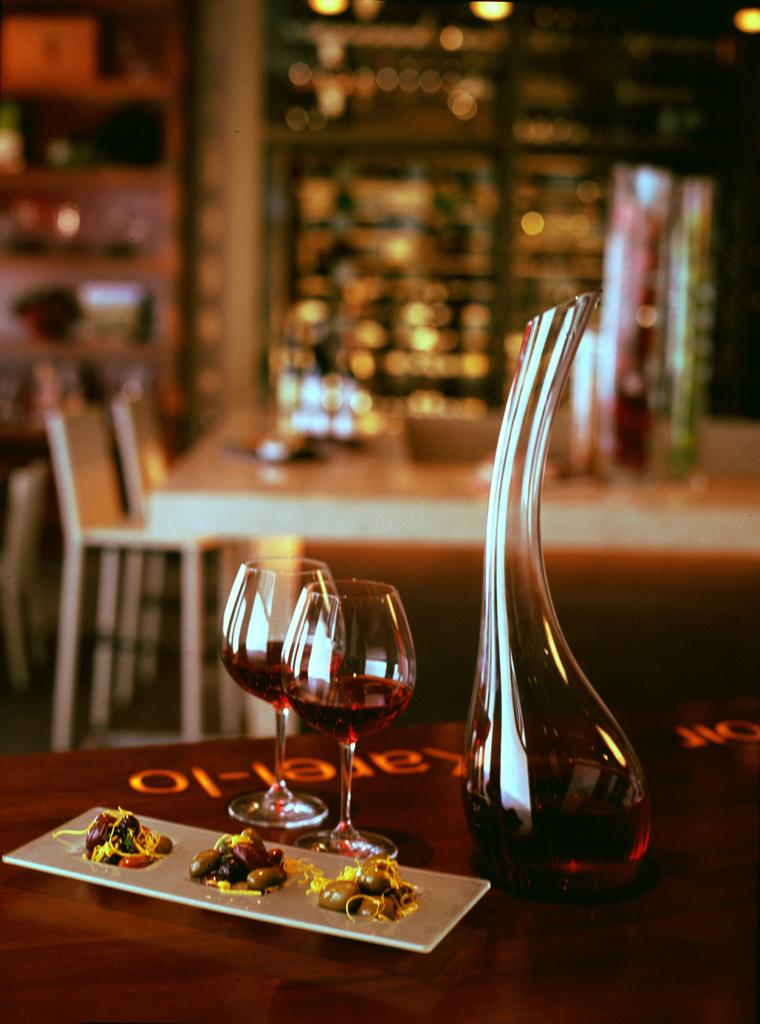What type of glassware can be seen in the image? There are two wine glasses in the image. What other container is visible in the image? There is a glass jar in the image. What might be used for serving food in the image? There is a food plate in the image. What is the price of the operation performed in the image? There is no operation or price mentioned in the image; it only features wine glasses, a glass jar, and a food plate. 